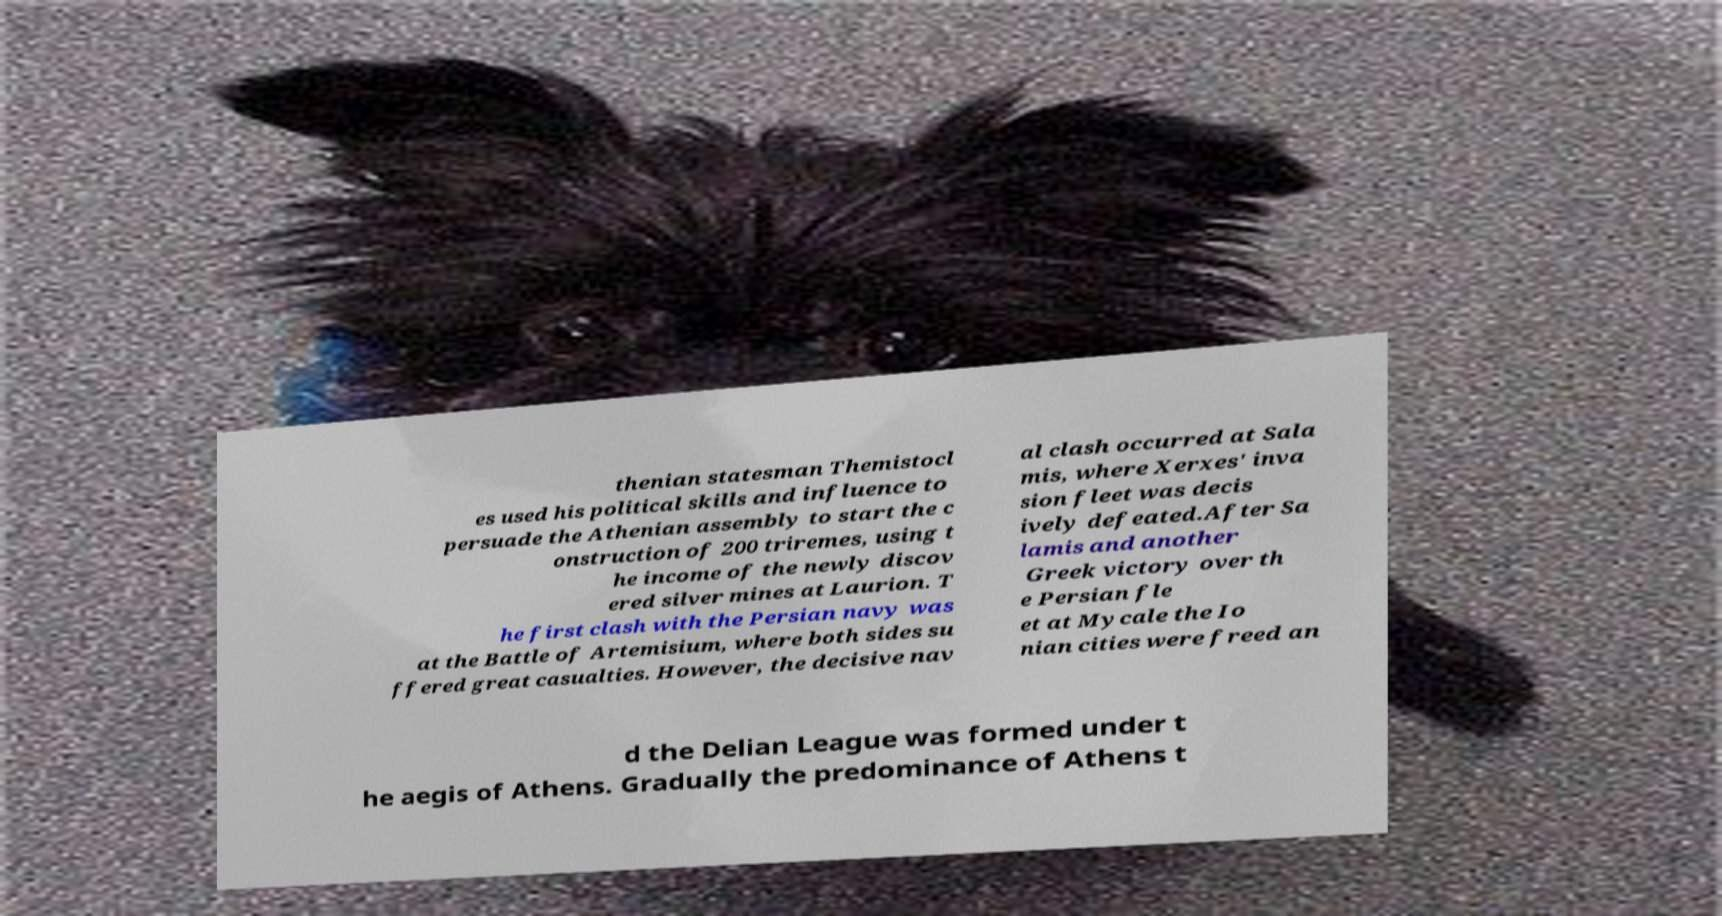I need the written content from this picture converted into text. Can you do that? thenian statesman Themistocl es used his political skills and influence to persuade the Athenian assembly to start the c onstruction of 200 triremes, using t he income of the newly discov ered silver mines at Laurion. T he first clash with the Persian navy was at the Battle of Artemisium, where both sides su ffered great casualties. However, the decisive nav al clash occurred at Sala mis, where Xerxes' inva sion fleet was decis ively defeated.After Sa lamis and another Greek victory over th e Persian fle et at Mycale the Io nian cities were freed an d the Delian League was formed under t he aegis of Athens. Gradually the predominance of Athens t 